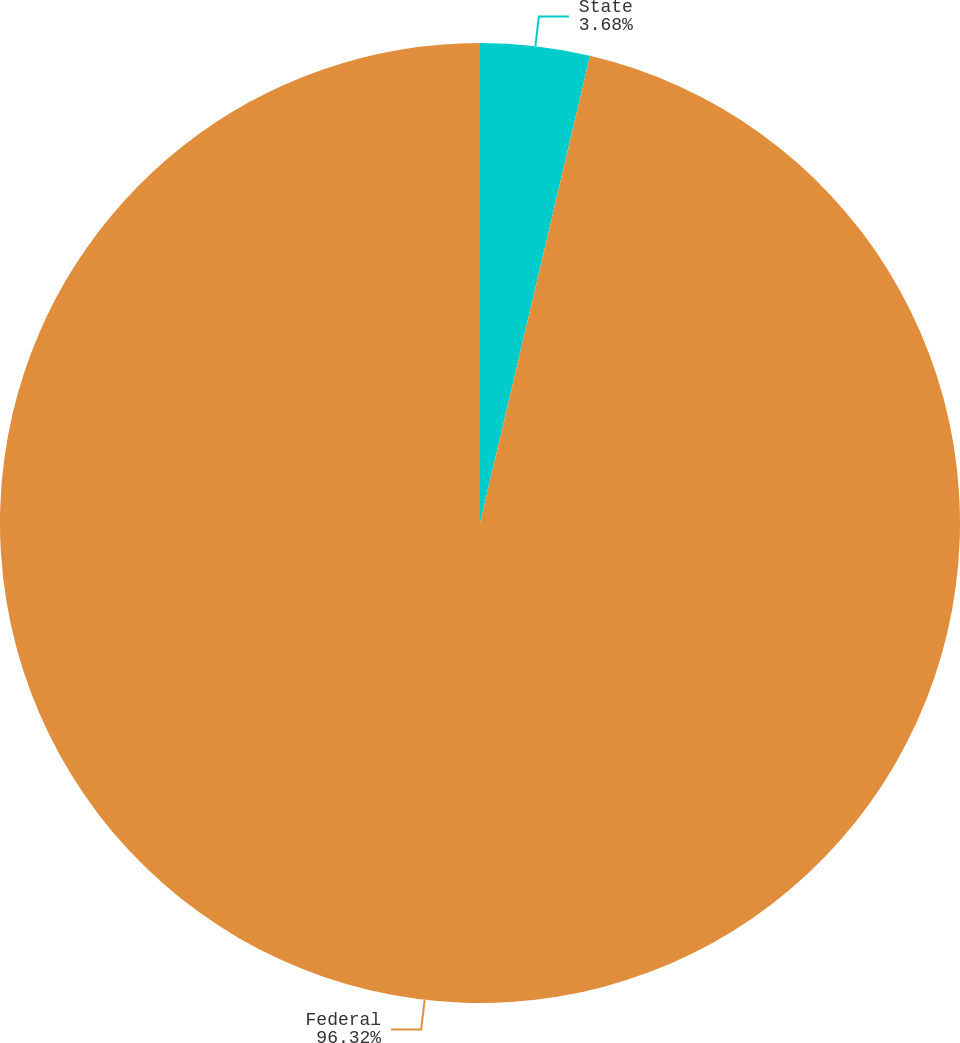<chart> <loc_0><loc_0><loc_500><loc_500><pie_chart><fcel>State<fcel>Federal<nl><fcel>3.68%<fcel>96.32%<nl></chart> 